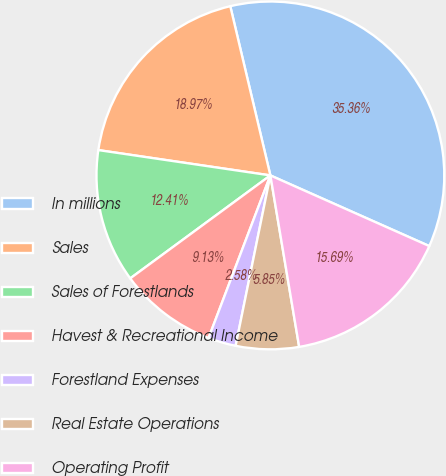Convert chart. <chart><loc_0><loc_0><loc_500><loc_500><pie_chart><fcel>In millions<fcel>Sales<fcel>Sales of Forestlands<fcel>Havest & Recreational Income<fcel>Forestland Expenses<fcel>Real Estate Operations<fcel>Operating Profit<nl><fcel>35.36%<fcel>18.97%<fcel>12.41%<fcel>9.13%<fcel>2.58%<fcel>5.85%<fcel>15.69%<nl></chart> 